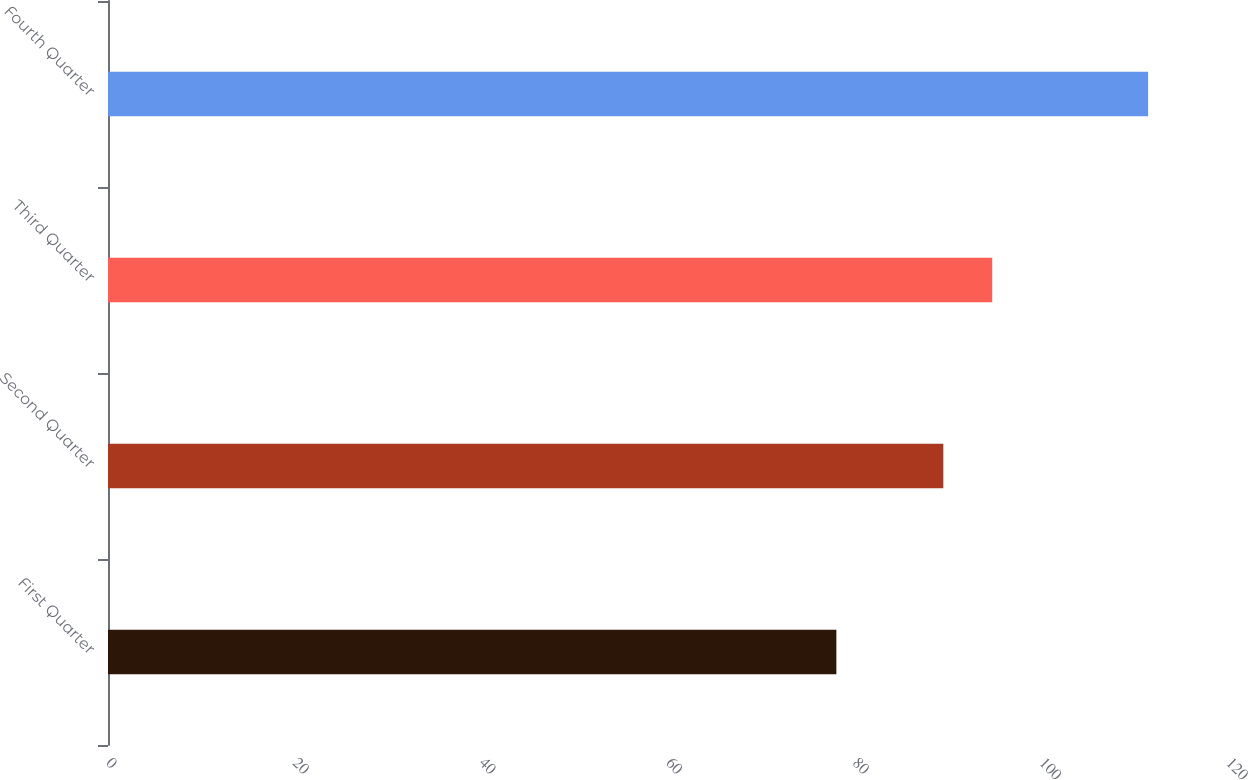Convert chart. <chart><loc_0><loc_0><loc_500><loc_500><bar_chart><fcel>First Quarter<fcel>Second Quarter<fcel>Third Quarter<fcel>Fourth Quarter<nl><fcel>78.04<fcel>89.5<fcel>94.74<fcel>111.44<nl></chart> 